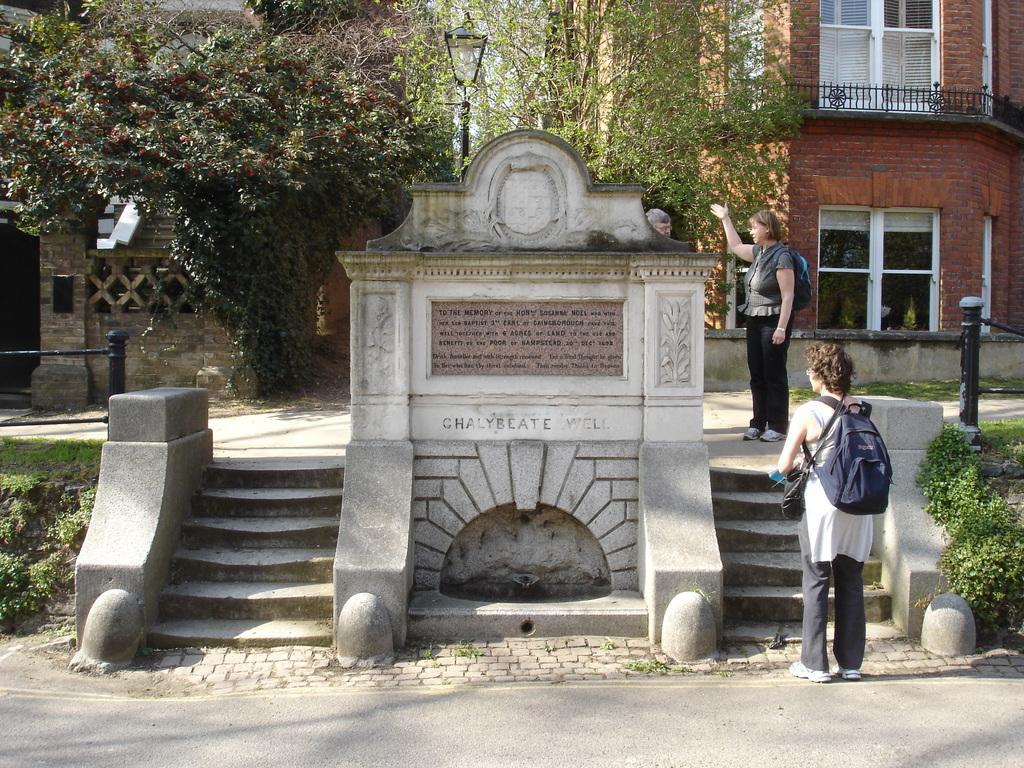How would you summarize this image in a sentence or two? In the image there is a monument and there are steps on the either side of that, there are three people on the right side and in the background there are some trees and on the right side there is a building. 